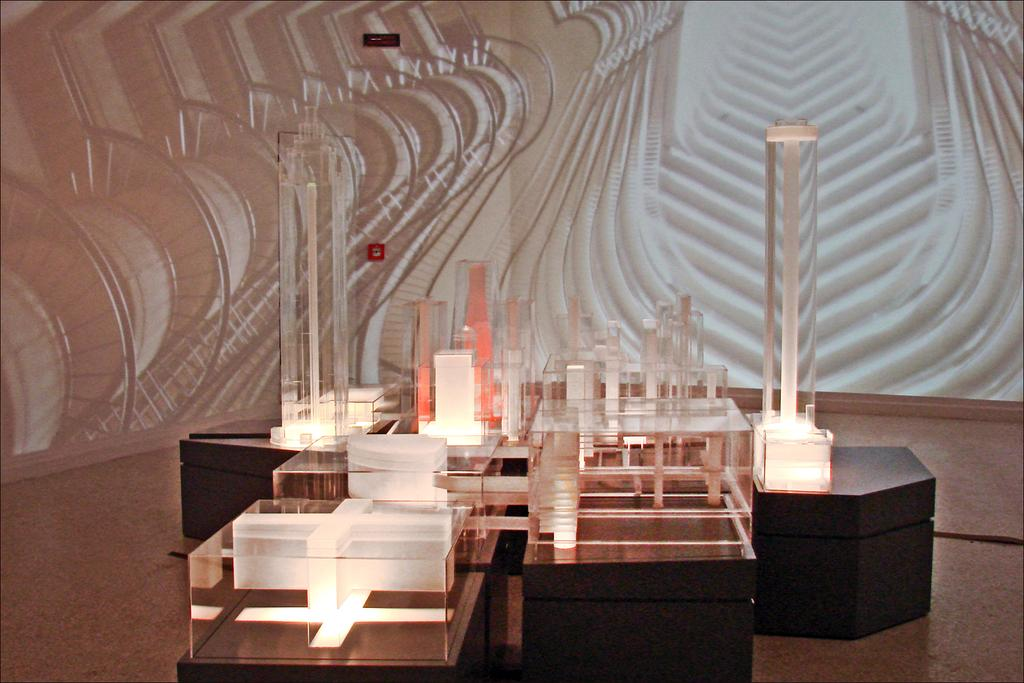What objects can be seen on the tables in the image? There are objects that look like lights and boxes on the tables. What can be seen on the wall in the background? There is a wall with a design in the background. What type of arch can be seen in the image? There is no arch present in the image. What is the quill used for in the image? There is no quill present in the image. 